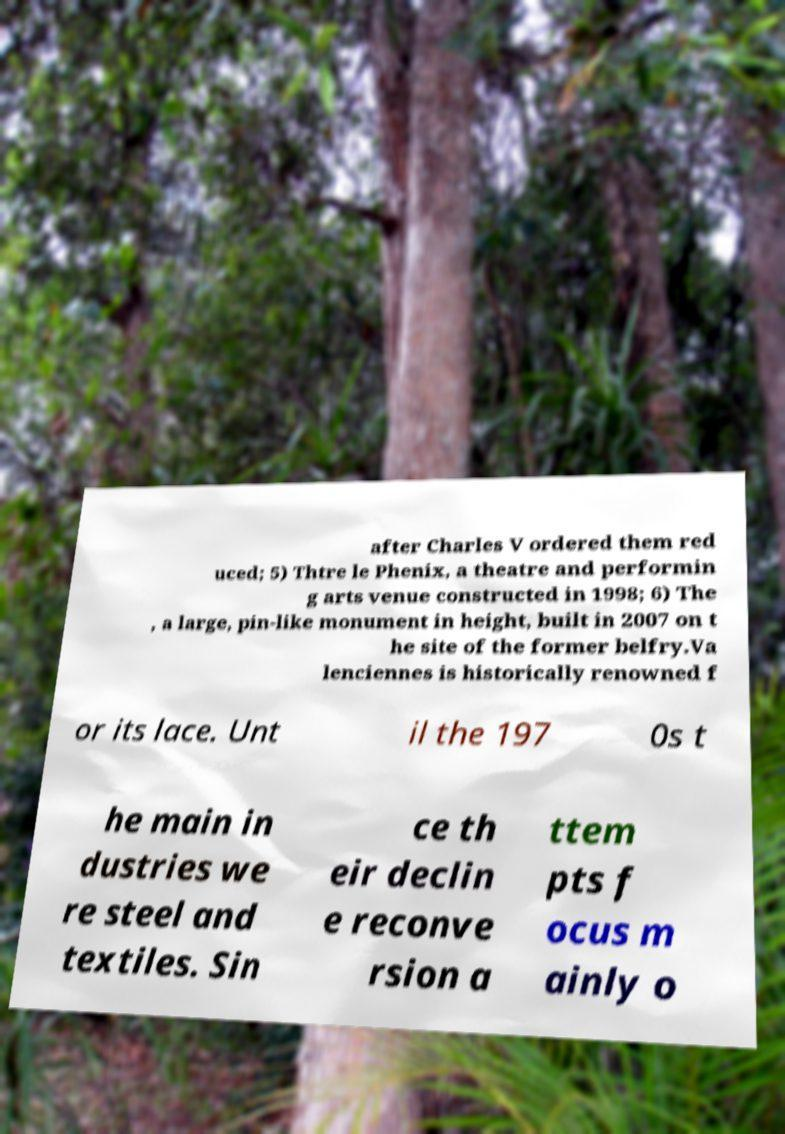I need the written content from this picture converted into text. Can you do that? after Charles V ordered them red uced; 5) Thtre le Phenix, a theatre and performin g arts venue constructed in 1998; 6) The , a large, pin-like monument in height, built in 2007 on t he site of the former belfry.Va lenciennes is historically renowned f or its lace. Unt il the 197 0s t he main in dustries we re steel and textiles. Sin ce th eir declin e reconve rsion a ttem pts f ocus m ainly o 